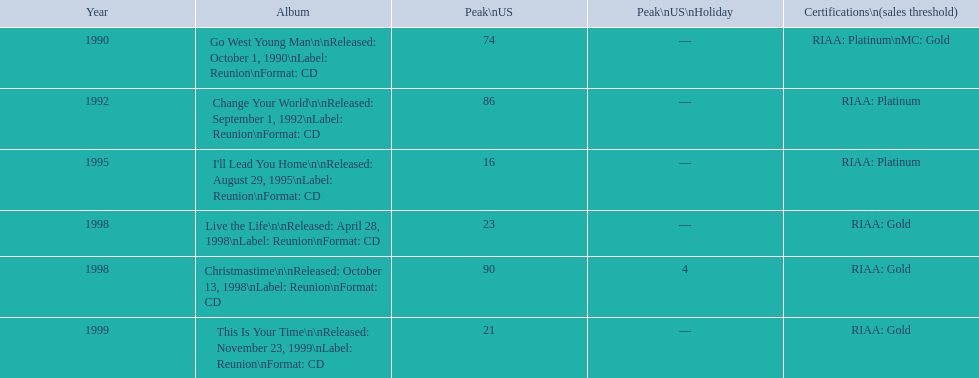Would you mind parsing the complete table? {'header': ['Year', 'Album', 'Peak\\nUS', 'Peak\\nUS\\nHoliday', 'Certifications\\n(sales threshold)'], 'rows': [['1990', 'Go West Young Man\\n\\nReleased: October 1, 1990\\nLabel: Reunion\\nFormat: CD', '74', '—', 'RIAA: Platinum\\nMC: Gold'], ['1992', 'Change Your World\\n\\nReleased: September 1, 1992\\nLabel: Reunion\\nFormat: CD', '86', '—', 'RIAA: Platinum'], ['1995', "I'll Lead You Home\\n\\nReleased: August 29, 1995\\nLabel: Reunion\\nFormat: CD", '16', '—', 'RIAA: Platinum'], ['1998', 'Live the Life\\n\\nReleased: April 28, 1998\\nLabel: Reunion\\nFormat: CD', '23', '—', 'RIAA: Gold'], ['1998', 'Christmastime\\n\\nReleased: October 13, 1998\\nLabel: Reunion\\nFormat: CD', '90', '4', 'RIAA: Gold'], ['1999', 'This Is Your Time\\n\\nReleased: November 23, 1999\\nLabel: Reunion\\nFormat: CD', '21', '—', 'RIAA: Gold']]} Which album by michael w. smith reached the highest spot on the us chart? I'll Lead You Home. 